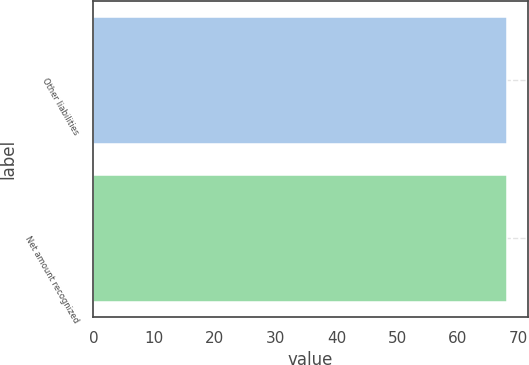<chart> <loc_0><loc_0><loc_500><loc_500><bar_chart><fcel>Other liabilities<fcel>Net amount recognized<nl><fcel>68<fcel>68.1<nl></chart> 